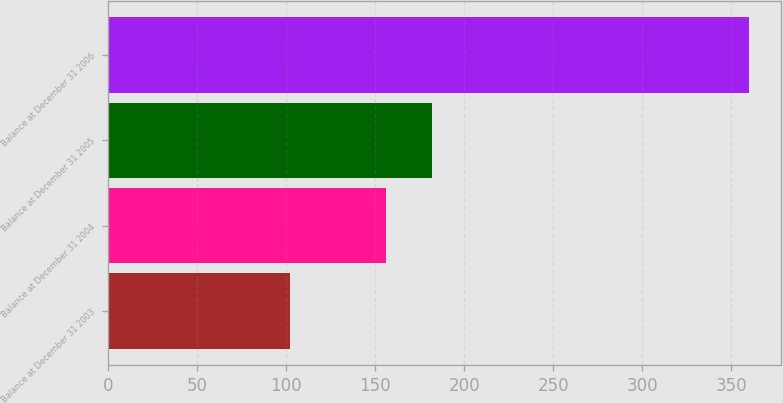Convert chart. <chart><loc_0><loc_0><loc_500><loc_500><bar_chart><fcel>Balance at December 31 2003<fcel>Balance at December 31 2004<fcel>Balance at December 31 2005<fcel>Balance at December 31 2006<nl><fcel>102<fcel>156<fcel>181.8<fcel>360<nl></chart> 